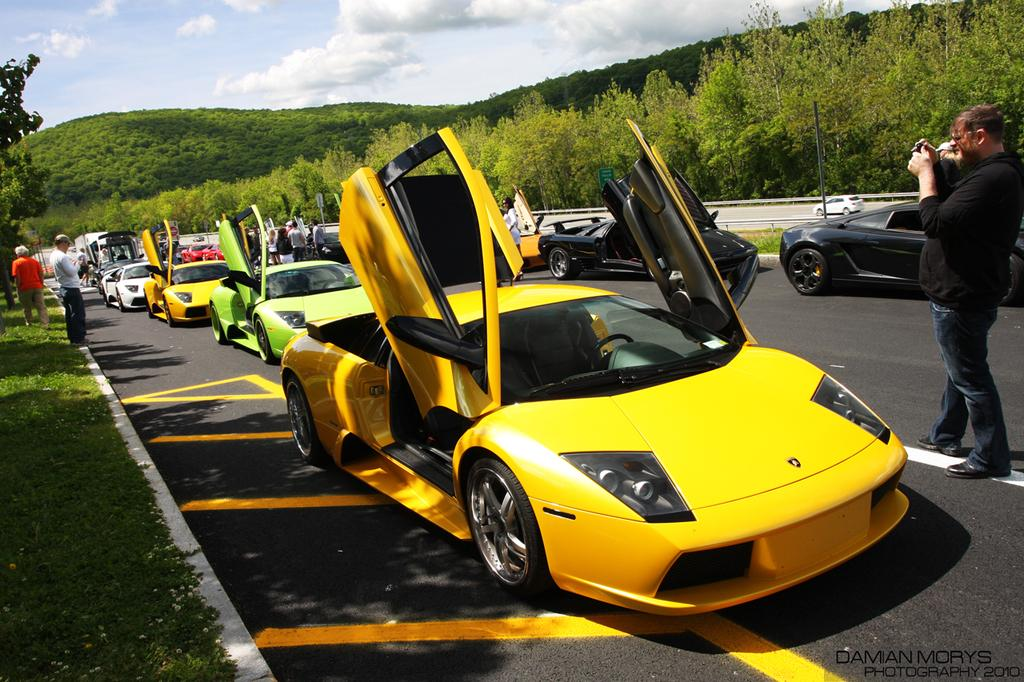What can be seen on the road in the image? There are vehicles on the road in the image. What else is present in the image besides the vehicles? There is a group of people standing in the image, as well as trees, hills, and the sky visible in the background. How many ladybugs can be seen on the water in the image? There are no ladybugs or water present in the image. What type of behavior can be observed in the group of people in the image? The provided facts do not give any information about the behavior of the group of people in the image. 